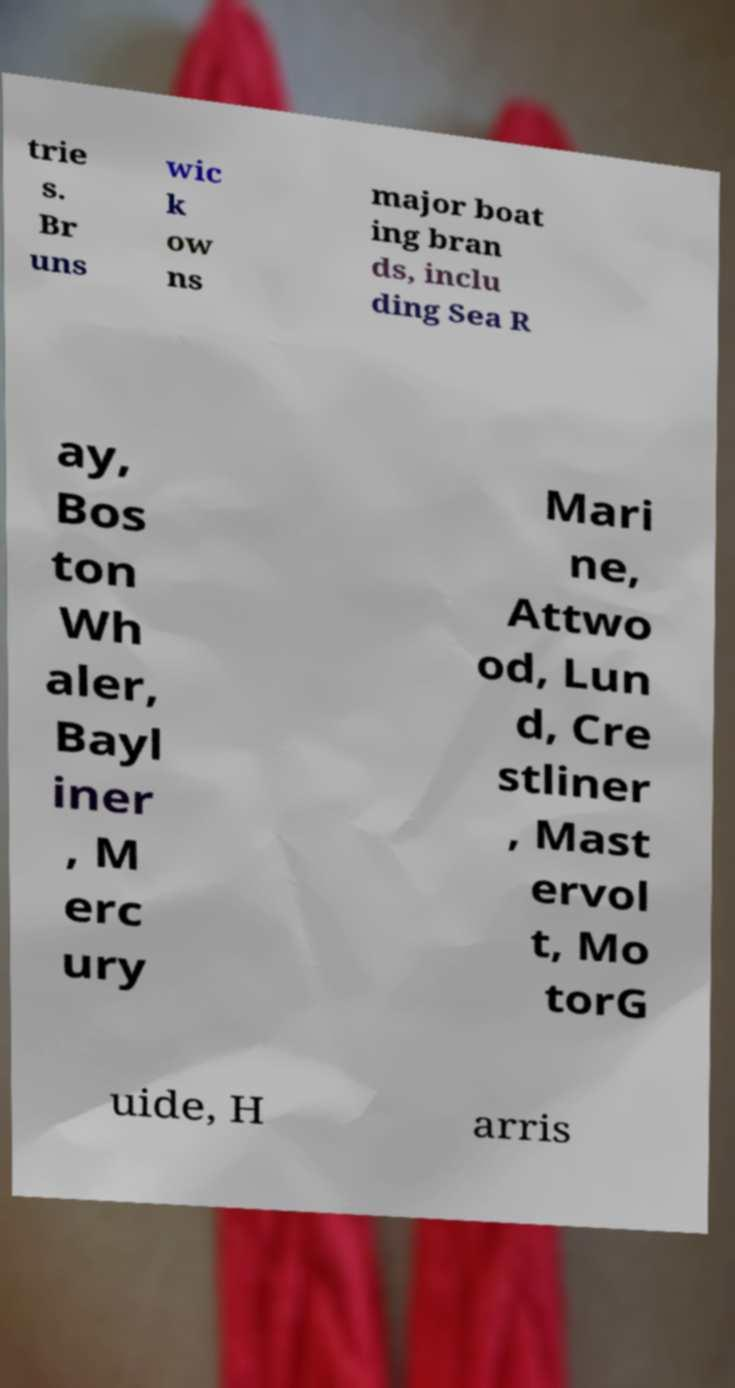Can you accurately transcribe the text from the provided image for me? trie s. Br uns wic k ow ns major boat ing bran ds, inclu ding Sea R ay, Bos ton Wh aler, Bayl iner , M erc ury Mari ne, Attwo od, Lun d, Cre stliner , Mast ervol t, Mo torG uide, H arris 